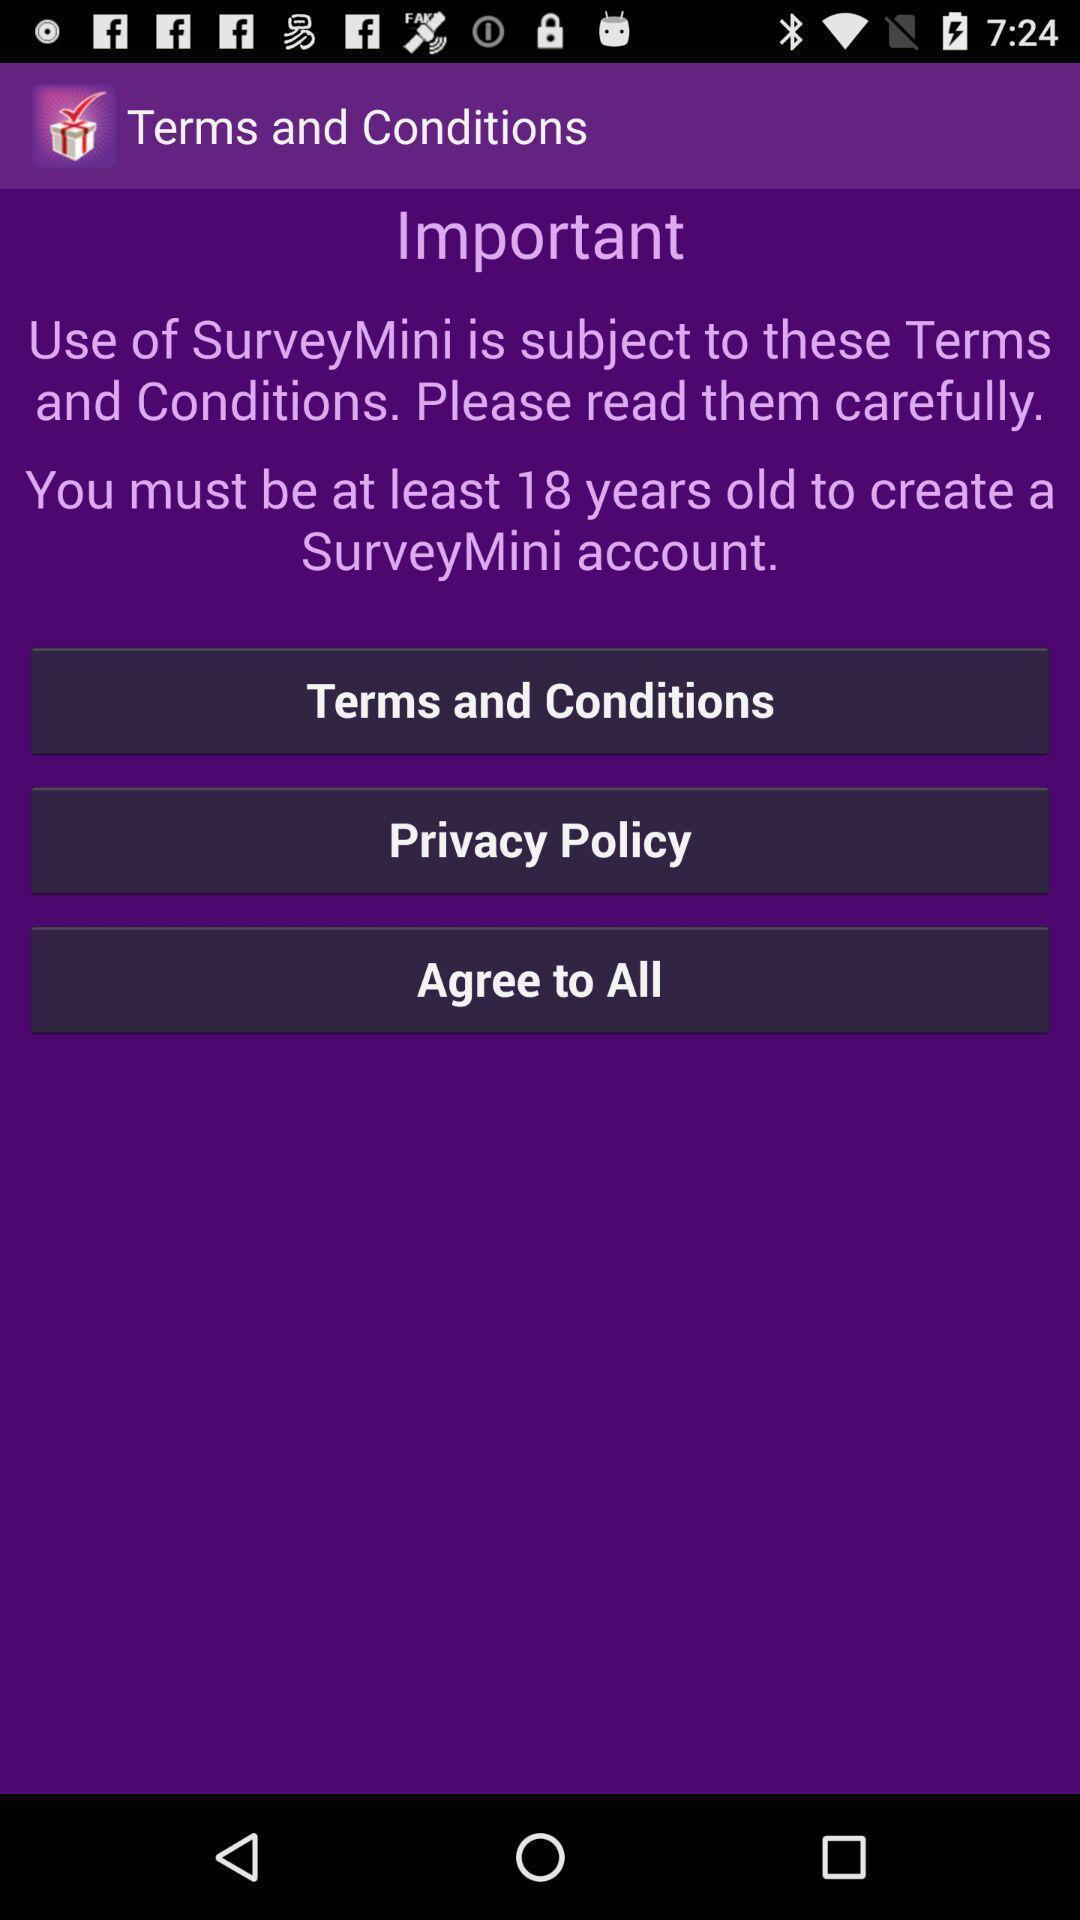Describe the key features of this screenshot. Screen displaying terms and conditions page. 